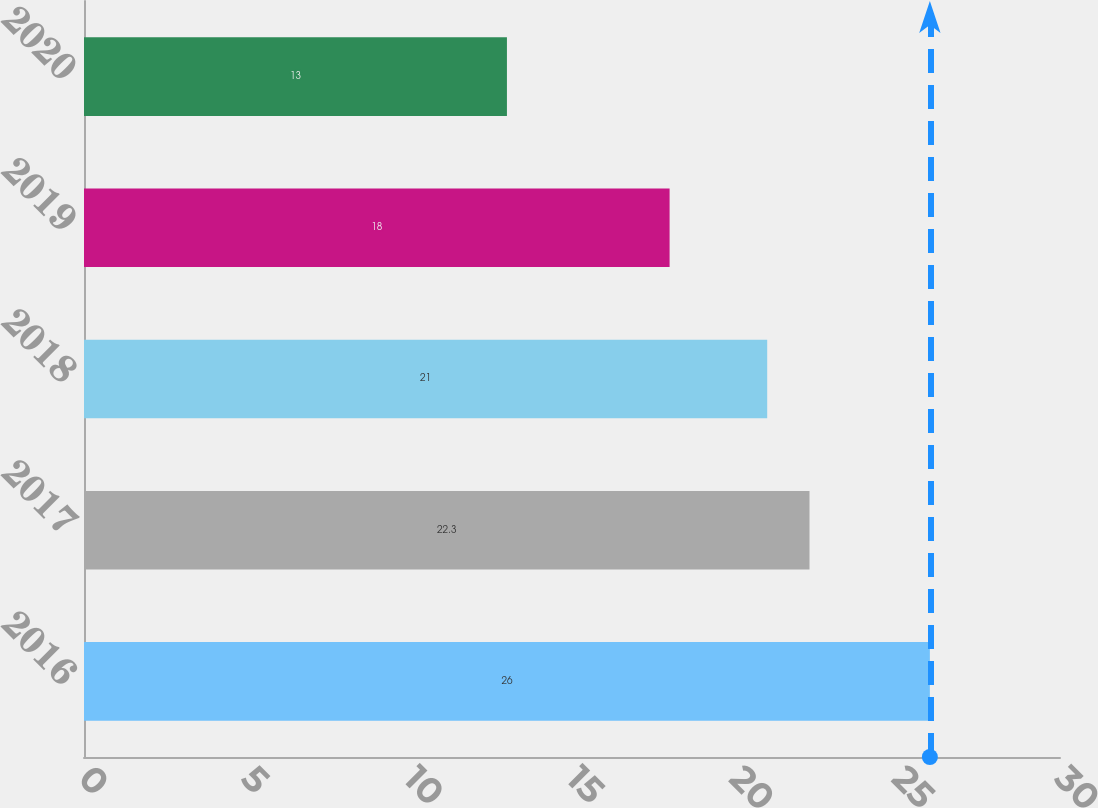<chart> <loc_0><loc_0><loc_500><loc_500><bar_chart><fcel>2016<fcel>2017<fcel>2018<fcel>2019<fcel>2020<nl><fcel>26<fcel>22.3<fcel>21<fcel>18<fcel>13<nl></chart> 